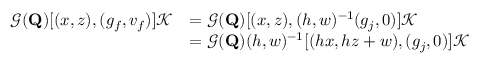Convert formula to latex. <formula><loc_0><loc_0><loc_500><loc_500>\begin{array} { r l } { \mathcal { G } ( Q ) [ ( x , z ) , ( g _ { f } , v _ { f } ) ] \mathcal { K } } & { = \mathcal { G } ( Q ) [ ( x , z ) , ( h , w ) ^ { - 1 } ( g _ { j } , 0 ) ] \mathcal { K } } \\ & { = \mathcal { G } ( Q ) ( h , w ) ^ { - 1 } [ ( h x , h z + w ) , ( g _ { j } , 0 ) ] \mathcal { K } } \end{array}</formula> 